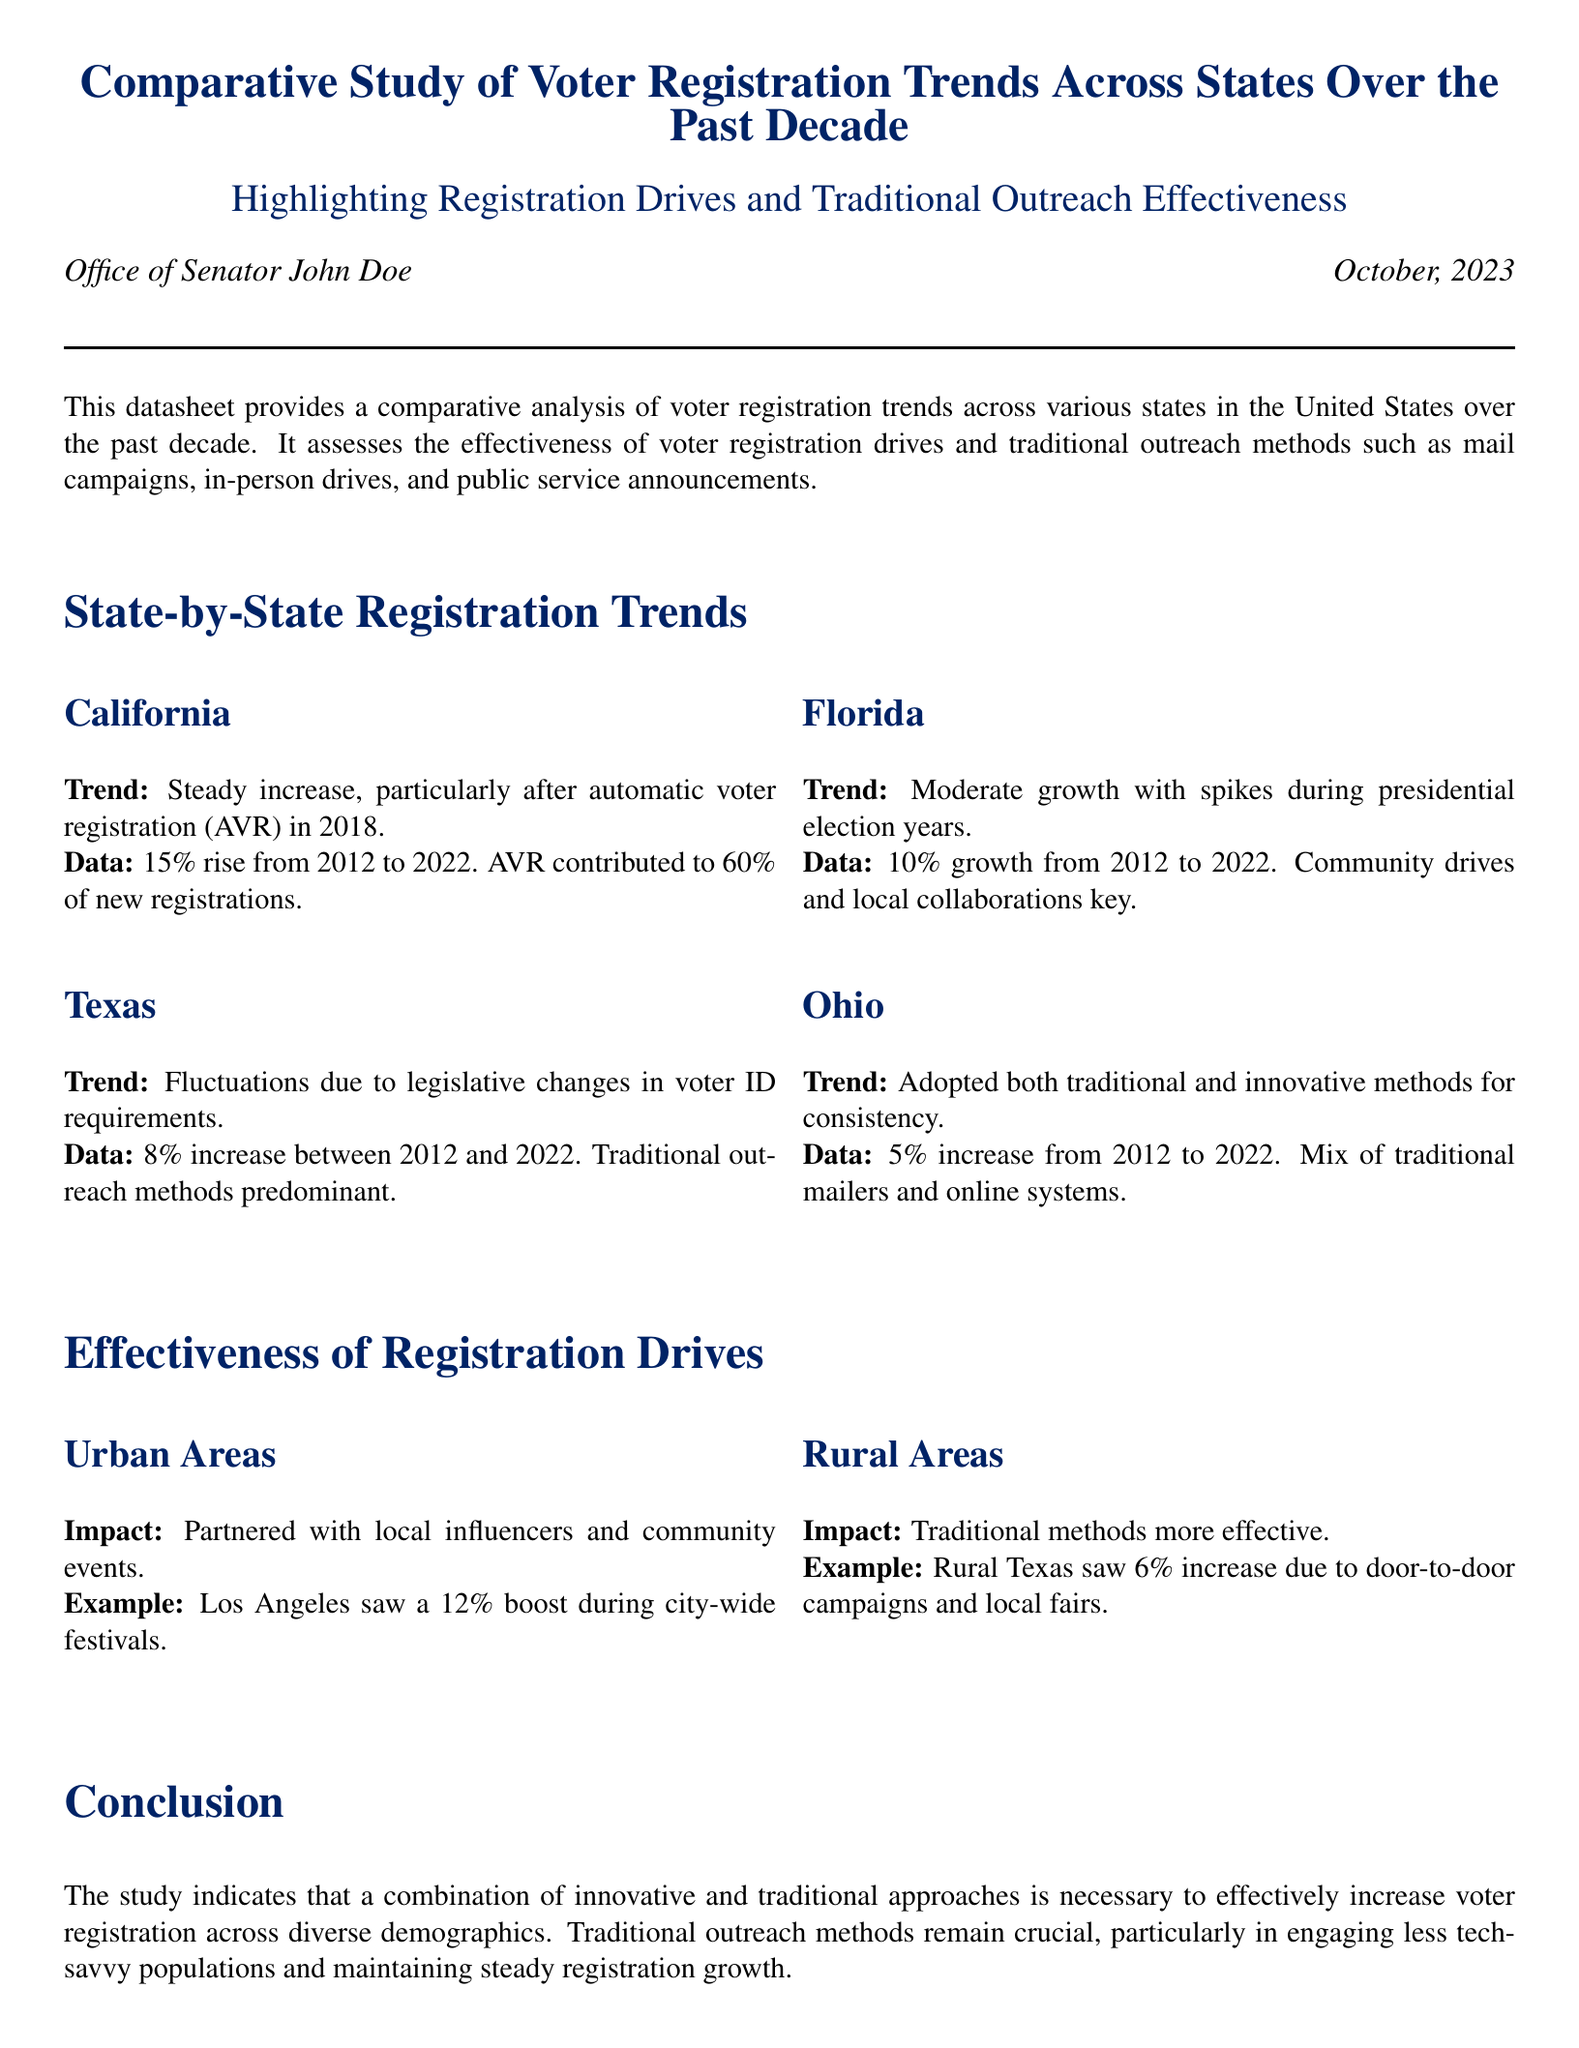What was the percentage increase in voter registration in California from 2012 to 2022? The data states that California saw a 15% rise in voter registration during this period.
Answer: 15% Which state experienced fluctuations in voter registration due to legislative changes? The document notes that Texas experienced fluctuations due to legislative changes in voter ID requirements.
Answer: Texas What was the percentage of new registrations attributed to automatic voter registration in California? The document mentions that AVR contributed to 60% of new registrations in California.
Answer: 60% How much did Ohio increase its voter registration from 2012 to 2022? Ohio had a 5% increase in voter registration according to the data provided.
Answer: 5% Which outreach method proved most effective in rural areas? The traditional methods, like door-to-door campaigns, were found to be more effective in rural areas.
Answer: Traditional methods In what year did California implement automatic voter registration? The datasheet specifies that California implemented AVR in 2018.
Answer: 2018 What type of outreach saw a 12% boost in voter registration in urban areas? The document notes that partnering with local influencers and community events led to a 12% boost in Los Angeles.
Answer: Partnering with local influencers Which demographic is mentioned as being less engaged with technology? The document indicates that less tech-savvy populations are those who are more engaged through traditional outreach methods.
Answer: Less tech-savvy populations What is the overall conclusion regarding registration methods? The conclusion emphasizes that a combination of innovative and traditional approaches is necessary for effective voter registration.
Answer: Combination of innovative and traditional approaches 